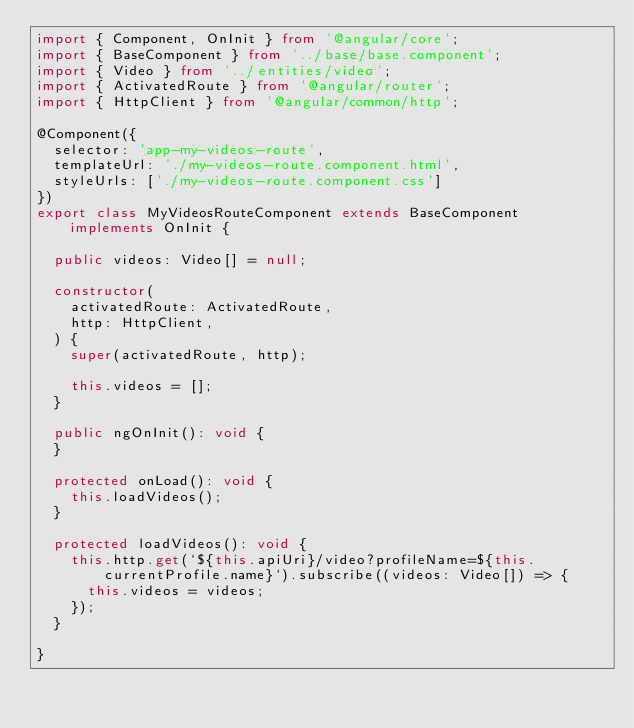<code> <loc_0><loc_0><loc_500><loc_500><_TypeScript_>import { Component, OnInit } from '@angular/core';
import { BaseComponent } from '../base/base.component';
import { Video } from '../entities/video';
import { ActivatedRoute } from '@angular/router';
import { HttpClient } from '@angular/common/http';

@Component({
  selector: 'app-my-videos-route',
  templateUrl: './my-videos-route.component.html',
  styleUrls: ['./my-videos-route.component.css']
})
export class MyVideosRouteComponent extends BaseComponent implements OnInit {

  public videos: Video[] = null;

  constructor(
    activatedRoute: ActivatedRoute,
    http: HttpClient,
  ) {
    super(activatedRoute, http);

    this.videos = [];
  }

  public ngOnInit(): void {
  }

  protected onLoad(): void {
    this.loadVideos();
  }

  protected loadVideos(): void {
    this.http.get(`${this.apiUri}/video?profileName=${this.currentProfile.name}`).subscribe((videos: Video[]) => {
      this.videos = videos;
    });
  }

}
</code> 